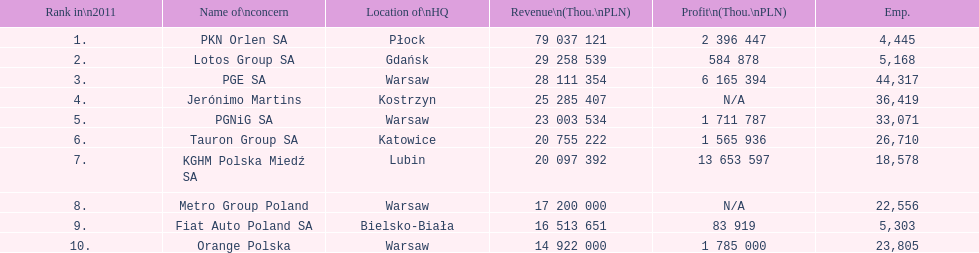Which company had the most employees? PGE SA. 